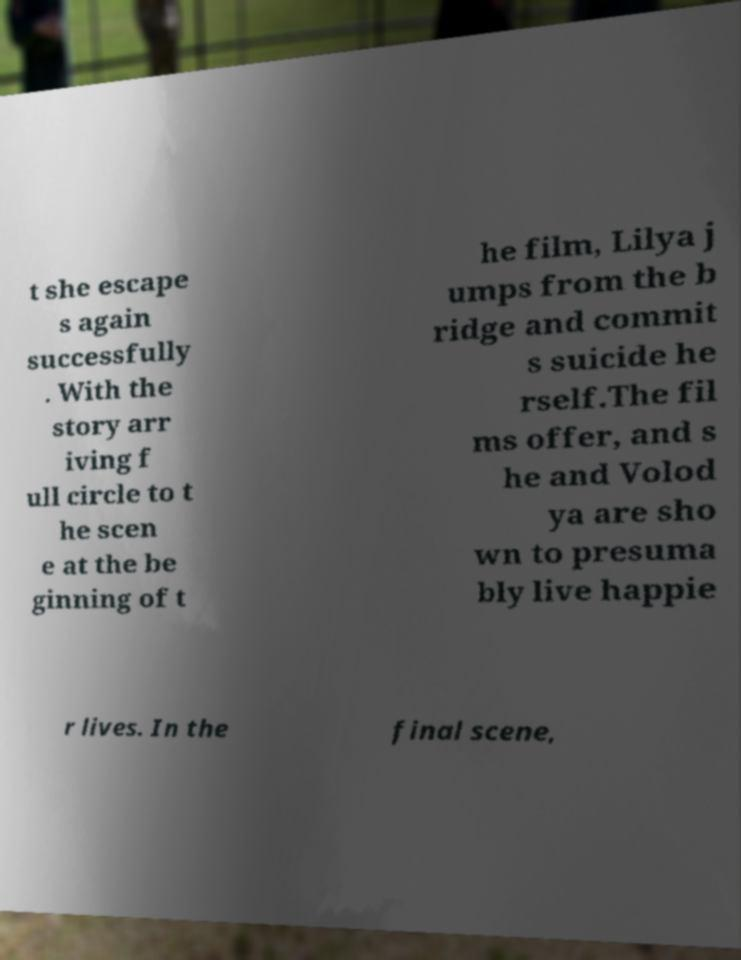What messages or text are displayed in this image? I need them in a readable, typed format. t she escape s again successfully . With the story arr iving f ull circle to t he scen e at the be ginning of t he film, Lilya j umps from the b ridge and commit s suicide he rself.The fil ms offer, and s he and Volod ya are sho wn to presuma bly live happie r lives. In the final scene, 